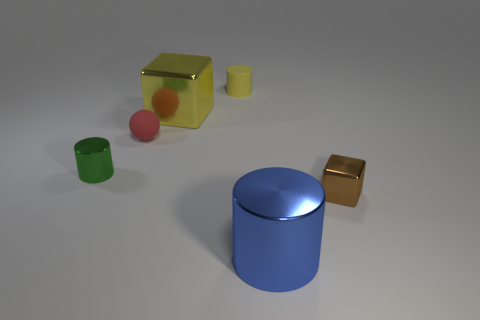There is a tiny rubber object that is the same shape as the small green metallic thing; what is its color?
Provide a succinct answer. Yellow. Is there any other thing that has the same color as the tiny cube?
Give a very brief answer. No. The shiny thing that is to the left of the small red thing that is on the left side of the block in front of the tiny green cylinder is what shape?
Make the answer very short. Cylinder. There is a metallic block that is behind the tiny brown cube; is it the same size as the metal object in front of the tiny shiny block?
Provide a succinct answer. Yes. How many other large blocks are made of the same material as the large block?
Offer a terse response. 0. Is the number of small green cylinders the same as the number of large purple cylinders?
Provide a short and direct response. No. There is a large metal object that is behind the metal object right of the blue shiny cylinder; what number of yellow objects are in front of it?
Make the answer very short. 0. Is the blue object the same shape as the small green object?
Provide a short and direct response. Yes. Is there another matte thing that has the same shape as the green thing?
Provide a short and direct response. Yes. The matte thing that is the same size as the sphere is what shape?
Provide a succinct answer. Cylinder. 